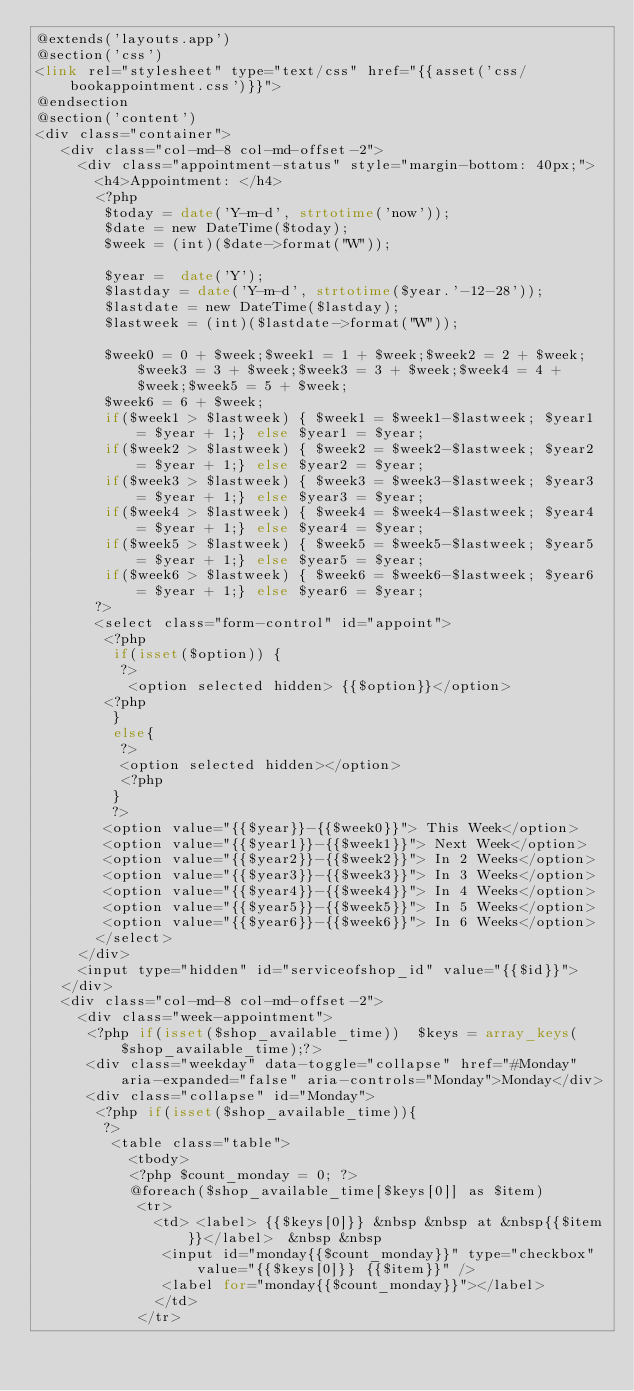Convert code to text. <code><loc_0><loc_0><loc_500><loc_500><_PHP_>@extends('layouts.app')
@section('css')
<link rel="stylesheet" type="text/css" href="{{asset('css/bookappointment.css')}}">
@endsection
@section('content')
<div class="container">
   <div class="col-md-8 col-md-offset-2">       
     <div class="appointment-status" style="margin-bottom: 40px;">
       <h4>Appointment: </h4>
       <?php
        $today = date('Y-m-d', strtotime('now'));
        $date = new DateTime($today);
        $week = (int)($date->format("W"));

        $year =  date('Y');
        $lastday = date('Y-m-d', strtotime($year.'-12-28'));
        $lastdate = new DateTime($lastday);
        $lastweek = (int)($lastdate->format("W"));

        $week0 = 0 + $week;$week1 = 1 + $week;$week2 = 2 + $week;$week3 = 3 + $week;$week3 = 3 + $week;$week4 = 4 + $week;$week5 = 5 + $week;
        $week6 = 6 + $week;
        if($week1 > $lastweek) { $week1 = $week1-$lastweek; $year1 = $year + 1;} else $year1 = $year;
        if($week2 > $lastweek) { $week2 = $week2-$lastweek; $year2 = $year + 1;} else $year2 = $year;
        if($week3 > $lastweek) { $week3 = $week3-$lastweek; $year3 = $year + 1;} else $year3 = $year;
        if($week4 > $lastweek) { $week4 = $week4-$lastweek; $year4 = $year + 1;} else $year4 = $year;
        if($week5 > $lastweek) { $week5 = $week5-$lastweek; $year5 = $year + 1;} else $year5 = $year;
        if($week6 > $lastweek) { $week6 = $week6-$lastweek; $year6 = $year + 1;} else $year6 = $year;
       ?>
       <select class="form-control" id="appoint">    
        <?php
         if(isset($option)) {
          ?>
           <option selected hidden> {{$option}}</option>   
        <?php
         }
         else{
          ?>
          <option selected hidden></option>
          <?php
         }
         ?>            
        <option value="{{$year}}-{{$week0}}"> This Week</option>
        <option value="{{$year1}}-{{$week1}}"> Next Week</option>
        <option value="{{$year2}}-{{$week2}}"> In 2 Weeks</option>
        <option value="{{$year3}}-{{$week3}}"> In 3 Weeks</option>
        <option value="{{$year4}}-{{$week4}}"> In 4 Weeks</option>
        <option value="{{$year5}}-{{$week5}}"> In 5 Weeks</option>   
        <option value="{{$year6}}-{{$week6}}"> In 6 Weeks</option>                   
       </select>
     </div>
     <input type="hidden" id="serviceofshop_id" value="{{$id}}">
   </div>
   <div class="col-md-8 col-md-offset-2">    
     <div class="week-appointment">
      <?php if(isset($shop_available_time))  $keys = array_keys($shop_available_time);?>
      <div class="weekday" data-toggle="collapse" href="#Monday" aria-expanded="false" aria-controls="Monday">Monday</div>    
      <div class="collapse" id="Monday">
       <?php if(isset($shop_available_time)){
        ?>
         <table class="table">
           <tbody>
           <?php $count_monday = 0; ?>
           @foreach($shop_available_time[$keys[0]] as $item)
            <tr>
              <td> <label> {{$keys[0]}} &nbsp &nbsp at &nbsp{{$item}}</label>  &nbsp &nbsp             
               <input id="monday{{$count_monday}}" type="checkbox" value="{{$keys[0]}} {{$item}}" />
               <label for="monday{{$count_monday}}"></label> 
              </td>
            </tr></code> 